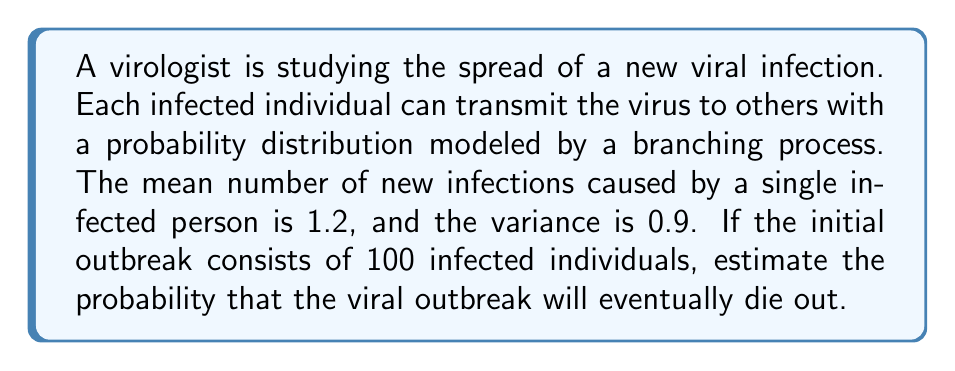Solve this math problem. To solve this problem, we'll use the theory of branching processes:

1) In a branching process, the probability of extinction is given by the smallest non-negative root of the equation:

   $$s = f(s)$$

   where $f(s)$ is the probability generating function of the offspring distribution.

2) We don't know the exact distribution, but we know its mean ($\mu$) and variance ($\sigma^2$). We can approximate $f(s)$ using a second-order Taylor expansion:

   $$f(s) \approx f(1) + f'(1)(s-1) + \frac{1}{2}f''(1)(s-1)^2$$

3) We know that:
   - $f(1) = 1$ (probability of any number of offspring is 1)
   - $f'(1) = \mu = 1.2$ (mean)
   - $f''(1) = \sigma^2 + \mu - \mu^2 = 0.9 + 1.2 - 1.2^2 = 0.66$

4) Substituting these into our equation:

   $$s \approx 1 + 1.2(s-1) + \frac{1}{2}(0.66)(s-1)^2$$

5) Simplifying:

   $$0 \approx 0.2(s-1) + 0.33(s-1)^2$$

6) Solving this quadratic equation:

   $$0.33s^2 + 0.2s - 0.53 = 0$$

   $$s = \frac{-0.2 \pm \sqrt{0.2^2 + 4(0.33)(0.53)}}{2(0.33)} \approx 0.8333 \text{ or } 1.9167$$

7) The smaller root, 0.8333, is the probability of extinction for a single infected individual.

8) For 100 initially infected individuals, the probability of eventual extinction is:

   $$P(\text{extinction}) = (0.8333)^{100} \approx 1.65 \times 10^{-8}$$

9) Therefore, the probability that the viral outbreak will not die out is:

   $$P(\text{not dying out}) = 1 - P(\text{extinction}) \approx 0.99999998$$
Answer: 0.99999998 